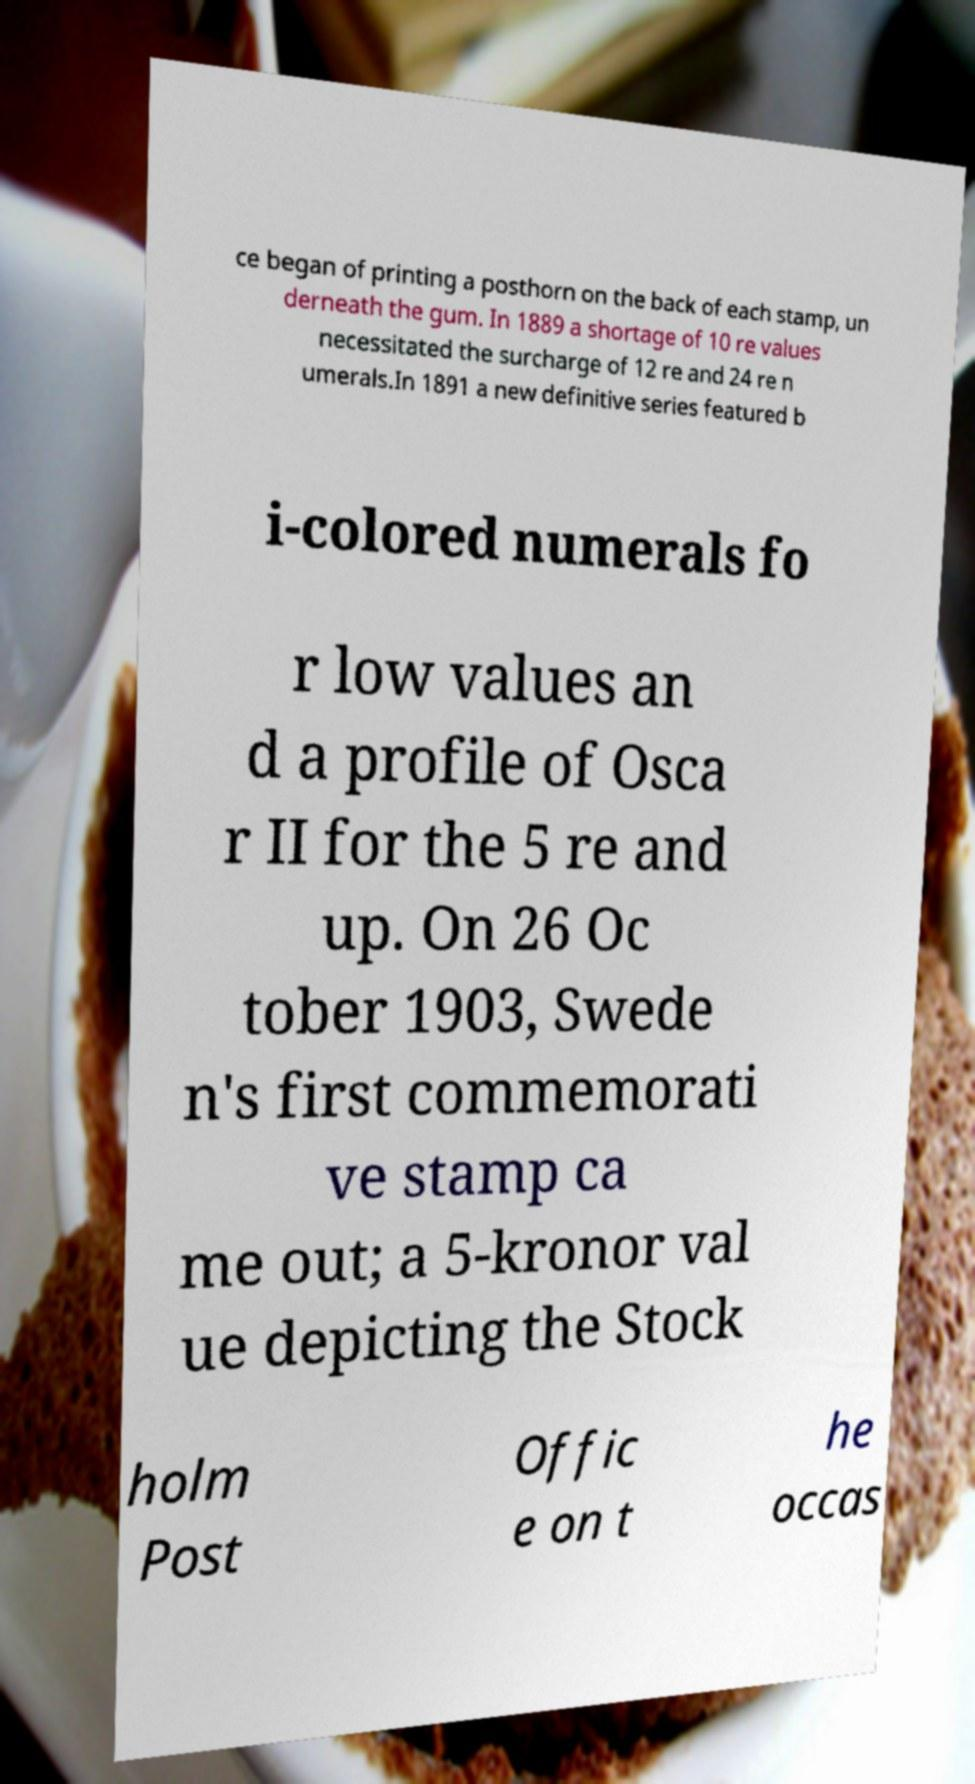Can you read and provide the text displayed in the image?This photo seems to have some interesting text. Can you extract and type it out for me? ce began of printing a posthorn on the back of each stamp, un derneath the gum. In 1889 a shortage of 10 re values necessitated the surcharge of 12 re and 24 re n umerals.In 1891 a new definitive series featured b i-colored numerals fo r low values an d a profile of Osca r II for the 5 re and up. On 26 Oc tober 1903, Swede n's first commemorati ve stamp ca me out; a 5-kronor val ue depicting the Stock holm Post Offic e on t he occas 